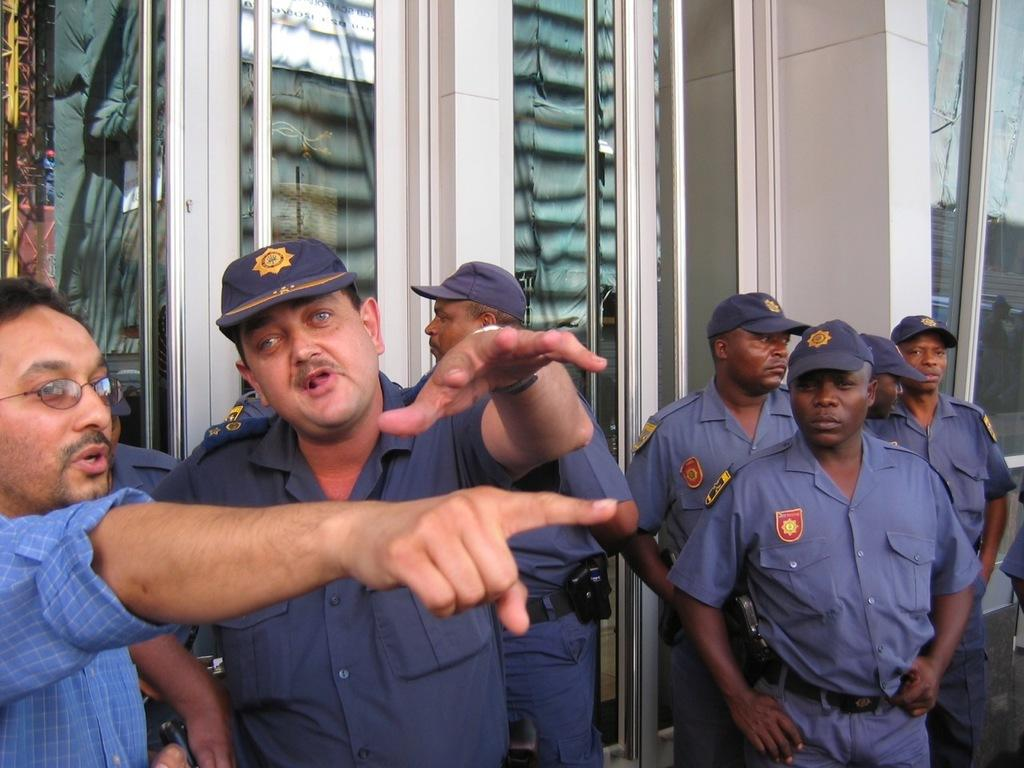What is happening in the image? There are people standing in the image. What can be seen in the background of the image? There is a building visible in the background of the image. What type of statement is being made by the scarf in the image? There is no scarf present in the image, so it cannot make any statements. 